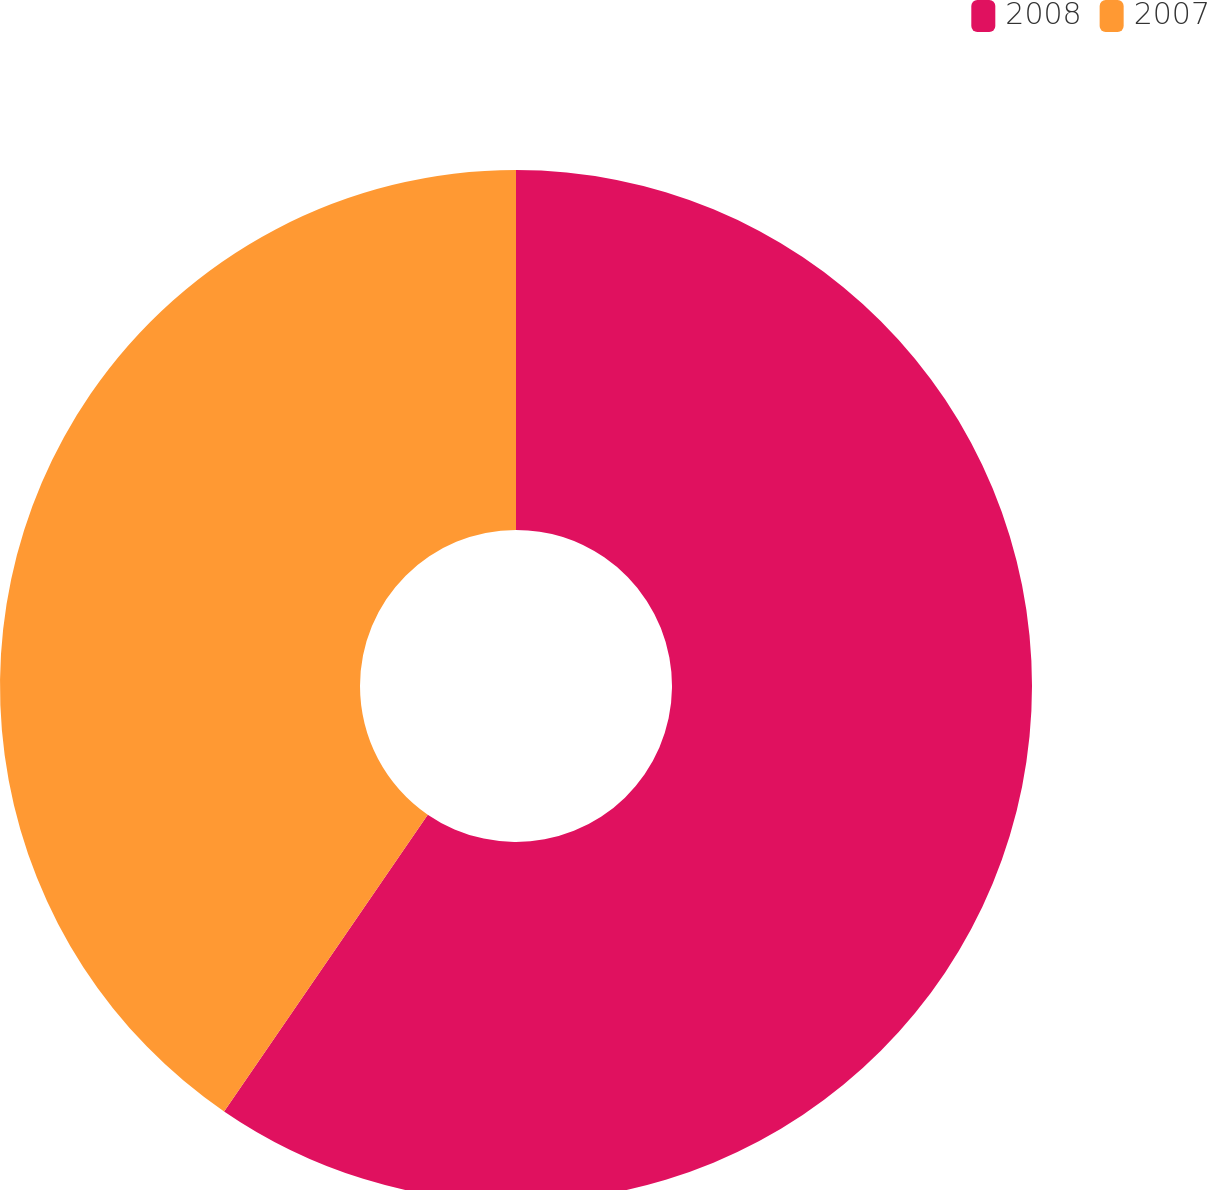<chart> <loc_0><loc_0><loc_500><loc_500><pie_chart><fcel>2008<fcel>2007<nl><fcel>59.57%<fcel>40.43%<nl></chart> 